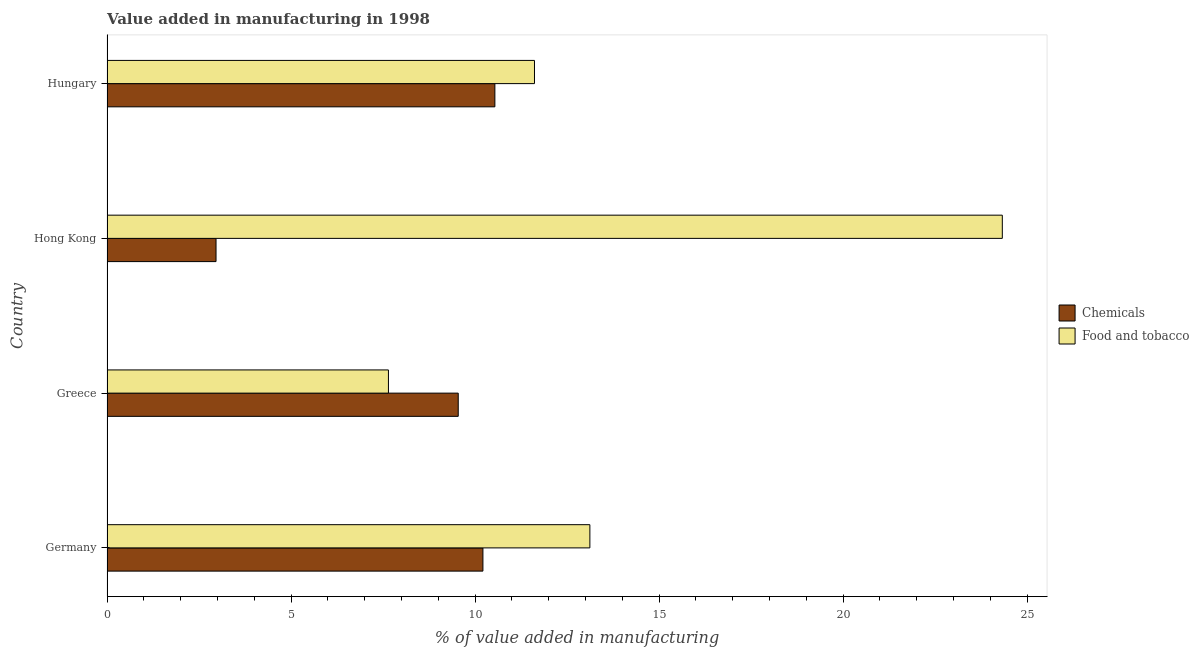How many groups of bars are there?
Your answer should be very brief. 4. Are the number of bars on each tick of the Y-axis equal?
Your answer should be compact. Yes. How many bars are there on the 3rd tick from the top?
Your answer should be very brief. 2. What is the label of the 4th group of bars from the top?
Keep it short and to the point. Germany. What is the value added by  manufacturing chemicals in Hong Kong?
Your response must be concise. 2.96. Across all countries, what is the maximum value added by  manufacturing chemicals?
Keep it short and to the point. 10.54. Across all countries, what is the minimum value added by manufacturing food and tobacco?
Your answer should be very brief. 7.65. In which country was the value added by  manufacturing chemicals maximum?
Provide a short and direct response. Hungary. In which country was the value added by  manufacturing chemicals minimum?
Provide a succinct answer. Hong Kong. What is the total value added by manufacturing food and tobacco in the graph?
Offer a very short reply. 56.71. What is the difference between the value added by  manufacturing chemicals in Germany and that in Hungary?
Your response must be concise. -0.33. What is the difference between the value added by  manufacturing chemicals in Hong Kong and the value added by manufacturing food and tobacco in Greece?
Your answer should be very brief. -4.69. What is the average value added by  manufacturing chemicals per country?
Give a very brief answer. 8.32. What is the difference between the value added by  manufacturing chemicals and value added by manufacturing food and tobacco in Greece?
Keep it short and to the point. 1.9. In how many countries, is the value added by  manufacturing chemicals greater than 9 %?
Offer a very short reply. 3. What is the ratio of the value added by  manufacturing chemicals in Hong Kong to that in Hungary?
Your answer should be compact. 0.28. Is the value added by  manufacturing chemicals in Hong Kong less than that in Hungary?
Ensure brevity in your answer.  Yes. What is the difference between the highest and the second highest value added by  manufacturing chemicals?
Ensure brevity in your answer.  0.33. What is the difference between the highest and the lowest value added by  manufacturing chemicals?
Keep it short and to the point. 7.58. In how many countries, is the value added by  manufacturing chemicals greater than the average value added by  manufacturing chemicals taken over all countries?
Make the answer very short. 3. Is the sum of the value added by  manufacturing chemicals in Hong Kong and Hungary greater than the maximum value added by manufacturing food and tobacco across all countries?
Your answer should be very brief. No. What does the 2nd bar from the top in Hong Kong represents?
Ensure brevity in your answer.  Chemicals. What does the 1st bar from the bottom in Germany represents?
Keep it short and to the point. Chemicals. Are all the bars in the graph horizontal?
Keep it short and to the point. Yes. Are the values on the major ticks of X-axis written in scientific E-notation?
Keep it short and to the point. No. Does the graph contain any zero values?
Your response must be concise. No. Does the graph contain grids?
Offer a very short reply. No. Where does the legend appear in the graph?
Your response must be concise. Center right. How many legend labels are there?
Keep it short and to the point. 2. What is the title of the graph?
Keep it short and to the point. Value added in manufacturing in 1998. What is the label or title of the X-axis?
Your answer should be very brief. % of value added in manufacturing. What is the % of value added in manufacturing of Chemicals in Germany?
Your response must be concise. 10.22. What is the % of value added in manufacturing of Food and tobacco in Germany?
Give a very brief answer. 13.12. What is the % of value added in manufacturing in Chemicals in Greece?
Make the answer very short. 9.54. What is the % of value added in manufacturing of Food and tobacco in Greece?
Your response must be concise. 7.65. What is the % of value added in manufacturing in Chemicals in Hong Kong?
Your answer should be compact. 2.96. What is the % of value added in manufacturing in Food and tobacco in Hong Kong?
Your answer should be compact. 24.33. What is the % of value added in manufacturing of Chemicals in Hungary?
Your answer should be compact. 10.54. What is the % of value added in manufacturing of Food and tobacco in Hungary?
Give a very brief answer. 11.62. Across all countries, what is the maximum % of value added in manufacturing in Chemicals?
Your answer should be very brief. 10.54. Across all countries, what is the maximum % of value added in manufacturing in Food and tobacco?
Provide a short and direct response. 24.33. Across all countries, what is the minimum % of value added in manufacturing in Chemicals?
Provide a succinct answer. 2.96. Across all countries, what is the minimum % of value added in manufacturing in Food and tobacco?
Offer a very short reply. 7.65. What is the total % of value added in manufacturing in Chemicals in the graph?
Offer a very short reply. 33.26. What is the total % of value added in manufacturing of Food and tobacco in the graph?
Offer a very short reply. 56.71. What is the difference between the % of value added in manufacturing of Chemicals in Germany and that in Greece?
Offer a very short reply. 0.67. What is the difference between the % of value added in manufacturing of Food and tobacco in Germany and that in Greece?
Give a very brief answer. 5.47. What is the difference between the % of value added in manufacturing in Chemicals in Germany and that in Hong Kong?
Offer a terse response. 7.25. What is the difference between the % of value added in manufacturing of Food and tobacco in Germany and that in Hong Kong?
Offer a very short reply. -11.21. What is the difference between the % of value added in manufacturing in Chemicals in Germany and that in Hungary?
Make the answer very short. -0.33. What is the difference between the % of value added in manufacturing in Food and tobacco in Germany and that in Hungary?
Your answer should be very brief. 1.51. What is the difference between the % of value added in manufacturing in Chemicals in Greece and that in Hong Kong?
Keep it short and to the point. 6.58. What is the difference between the % of value added in manufacturing of Food and tobacco in Greece and that in Hong Kong?
Your answer should be compact. -16.68. What is the difference between the % of value added in manufacturing in Chemicals in Greece and that in Hungary?
Your response must be concise. -1. What is the difference between the % of value added in manufacturing of Food and tobacco in Greece and that in Hungary?
Ensure brevity in your answer.  -3.97. What is the difference between the % of value added in manufacturing of Chemicals in Hong Kong and that in Hungary?
Your response must be concise. -7.58. What is the difference between the % of value added in manufacturing of Food and tobacco in Hong Kong and that in Hungary?
Provide a short and direct response. 12.71. What is the difference between the % of value added in manufacturing of Chemicals in Germany and the % of value added in manufacturing of Food and tobacco in Greece?
Your response must be concise. 2.57. What is the difference between the % of value added in manufacturing of Chemicals in Germany and the % of value added in manufacturing of Food and tobacco in Hong Kong?
Offer a terse response. -14.11. What is the difference between the % of value added in manufacturing of Chemicals in Germany and the % of value added in manufacturing of Food and tobacco in Hungary?
Make the answer very short. -1.4. What is the difference between the % of value added in manufacturing in Chemicals in Greece and the % of value added in manufacturing in Food and tobacco in Hong Kong?
Provide a succinct answer. -14.78. What is the difference between the % of value added in manufacturing of Chemicals in Greece and the % of value added in manufacturing of Food and tobacco in Hungary?
Your answer should be very brief. -2.07. What is the difference between the % of value added in manufacturing in Chemicals in Hong Kong and the % of value added in manufacturing in Food and tobacco in Hungary?
Your answer should be very brief. -8.65. What is the average % of value added in manufacturing of Chemicals per country?
Provide a short and direct response. 8.32. What is the average % of value added in manufacturing of Food and tobacco per country?
Your answer should be very brief. 14.18. What is the difference between the % of value added in manufacturing of Chemicals and % of value added in manufacturing of Food and tobacco in Germany?
Make the answer very short. -2.91. What is the difference between the % of value added in manufacturing of Chemicals and % of value added in manufacturing of Food and tobacco in Greece?
Provide a succinct answer. 1.9. What is the difference between the % of value added in manufacturing in Chemicals and % of value added in manufacturing in Food and tobacco in Hong Kong?
Offer a terse response. -21.37. What is the difference between the % of value added in manufacturing in Chemicals and % of value added in manufacturing in Food and tobacco in Hungary?
Provide a succinct answer. -1.08. What is the ratio of the % of value added in manufacturing of Chemicals in Germany to that in Greece?
Your answer should be very brief. 1.07. What is the ratio of the % of value added in manufacturing of Food and tobacco in Germany to that in Greece?
Make the answer very short. 1.72. What is the ratio of the % of value added in manufacturing in Chemicals in Germany to that in Hong Kong?
Provide a succinct answer. 3.45. What is the ratio of the % of value added in manufacturing in Food and tobacco in Germany to that in Hong Kong?
Keep it short and to the point. 0.54. What is the ratio of the % of value added in manufacturing of Chemicals in Germany to that in Hungary?
Keep it short and to the point. 0.97. What is the ratio of the % of value added in manufacturing of Food and tobacco in Germany to that in Hungary?
Offer a very short reply. 1.13. What is the ratio of the % of value added in manufacturing of Chemicals in Greece to that in Hong Kong?
Your answer should be compact. 3.22. What is the ratio of the % of value added in manufacturing of Food and tobacco in Greece to that in Hong Kong?
Give a very brief answer. 0.31. What is the ratio of the % of value added in manufacturing of Chemicals in Greece to that in Hungary?
Your response must be concise. 0.91. What is the ratio of the % of value added in manufacturing of Food and tobacco in Greece to that in Hungary?
Your answer should be very brief. 0.66. What is the ratio of the % of value added in manufacturing in Chemicals in Hong Kong to that in Hungary?
Give a very brief answer. 0.28. What is the ratio of the % of value added in manufacturing in Food and tobacco in Hong Kong to that in Hungary?
Ensure brevity in your answer.  2.09. What is the difference between the highest and the second highest % of value added in manufacturing of Chemicals?
Offer a terse response. 0.33. What is the difference between the highest and the second highest % of value added in manufacturing of Food and tobacco?
Give a very brief answer. 11.21. What is the difference between the highest and the lowest % of value added in manufacturing of Chemicals?
Make the answer very short. 7.58. What is the difference between the highest and the lowest % of value added in manufacturing of Food and tobacco?
Ensure brevity in your answer.  16.68. 